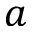<formula> <loc_0><loc_0><loc_500><loc_500>a</formula> 